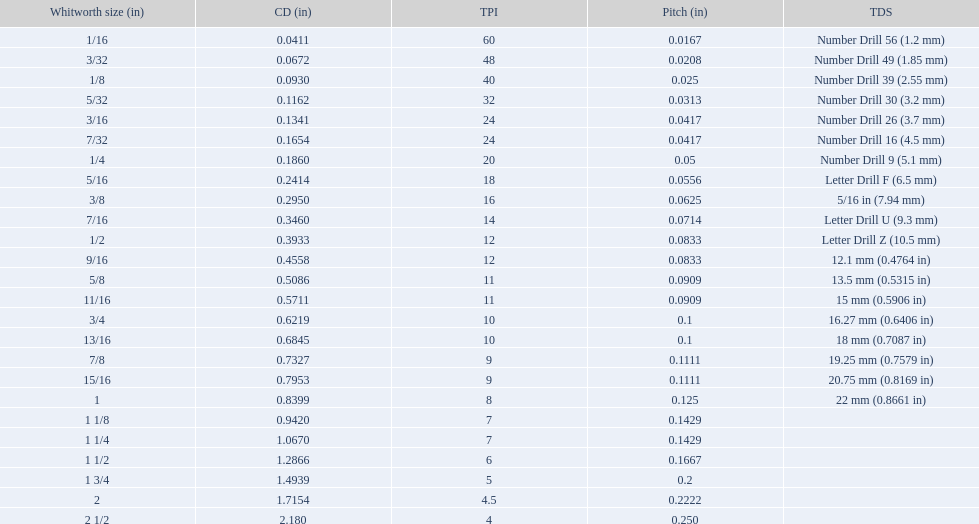What are all of the whitworth sizes? 1/16, 3/32, 1/8, 5/32, 3/16, 7/32, 1/4, 5/16, 3/8, 7/16, 1/2, 9/16, 5/8, 11/16, 3/4, 13/16, 7/8, 15/16, 1, 1 1/8, 1 1/4, 1 1/2, 1 3/4, 2, 2 1/2. How many threads per inch are in each size? 60, 48, 40, 32, 24, 24, 20, 18, 16, 14, 12, 12, 11, 11, 10, 10, 9, 9, 8, 7, 7, 6, 5, 4.5, 4. How many threads per inch are in the 3/16 size? 24. And which other size has the same number of threads? 7/32. 